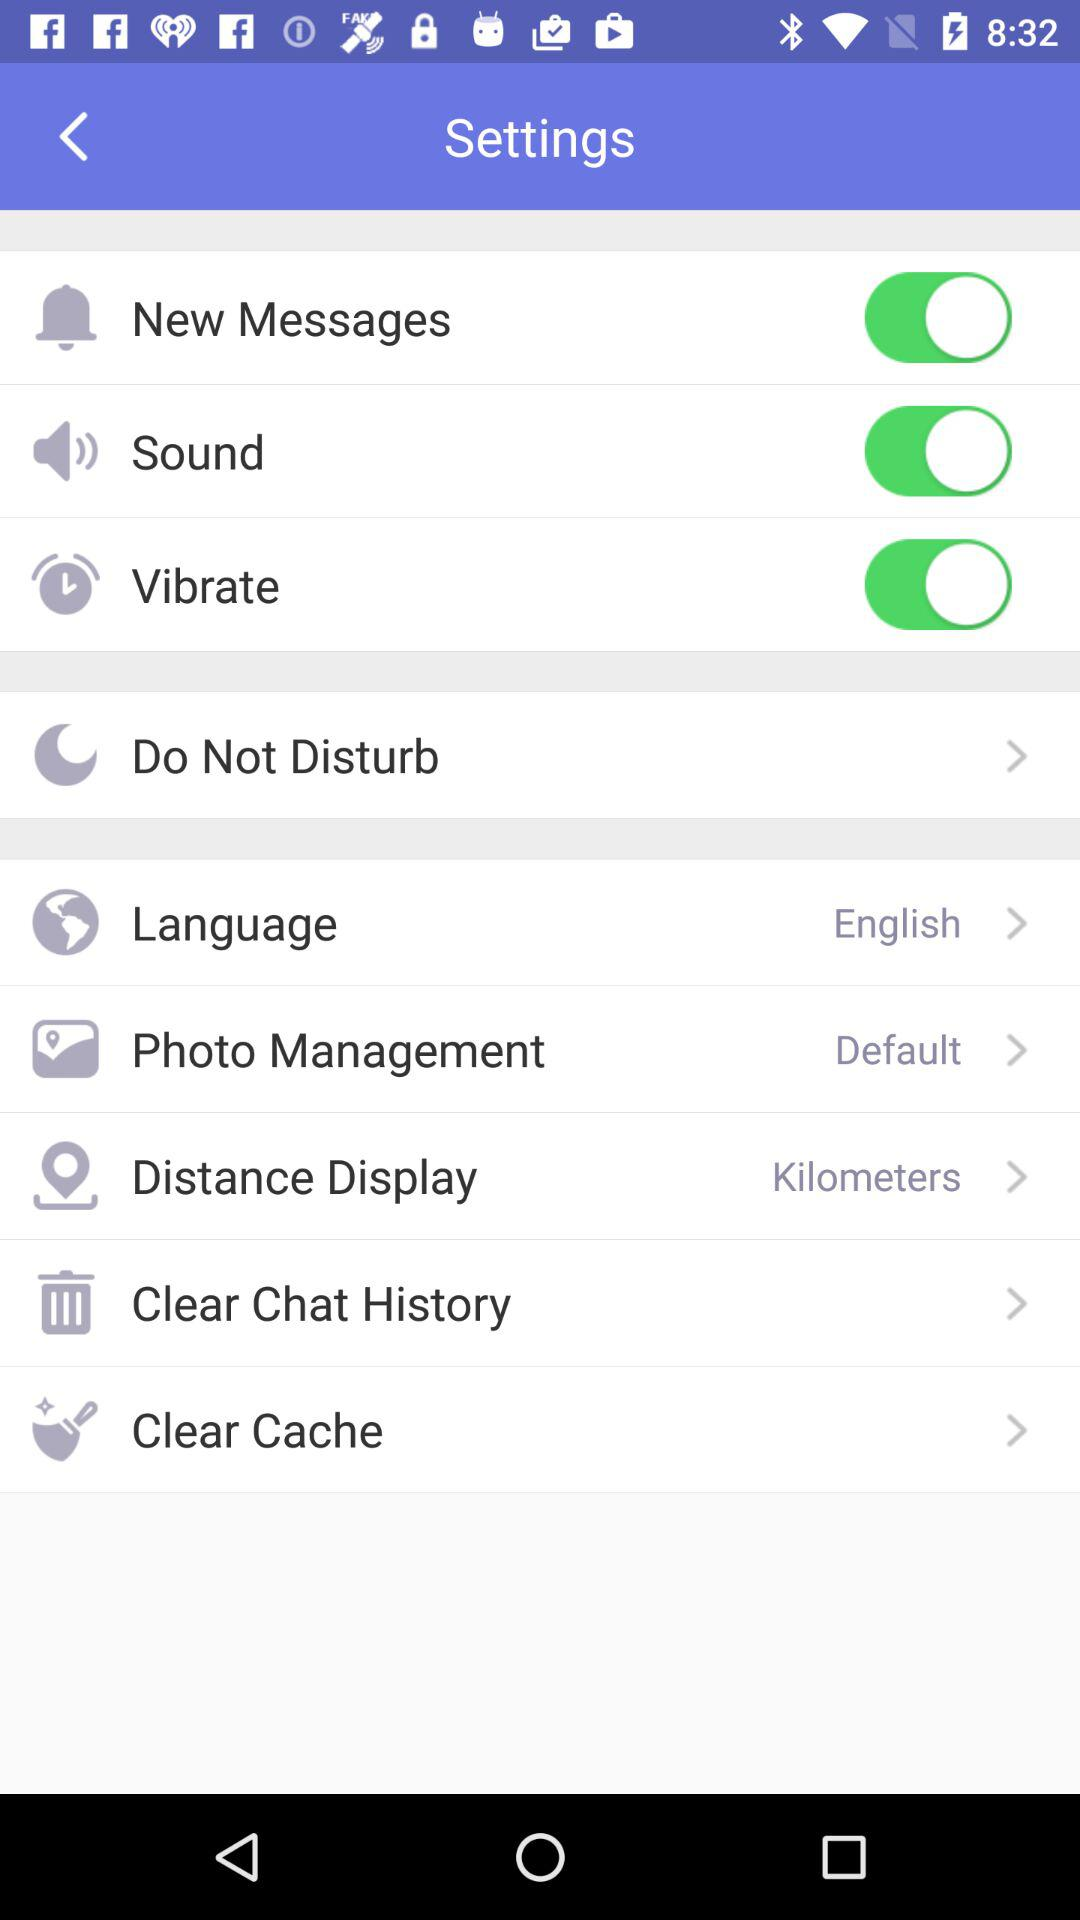Which language has been selected? The selected language is English. 